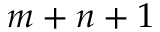Convert formula to latex. <formula><loc_0><loc_0><loc_500><loc_500>m + n + 1</formula> 